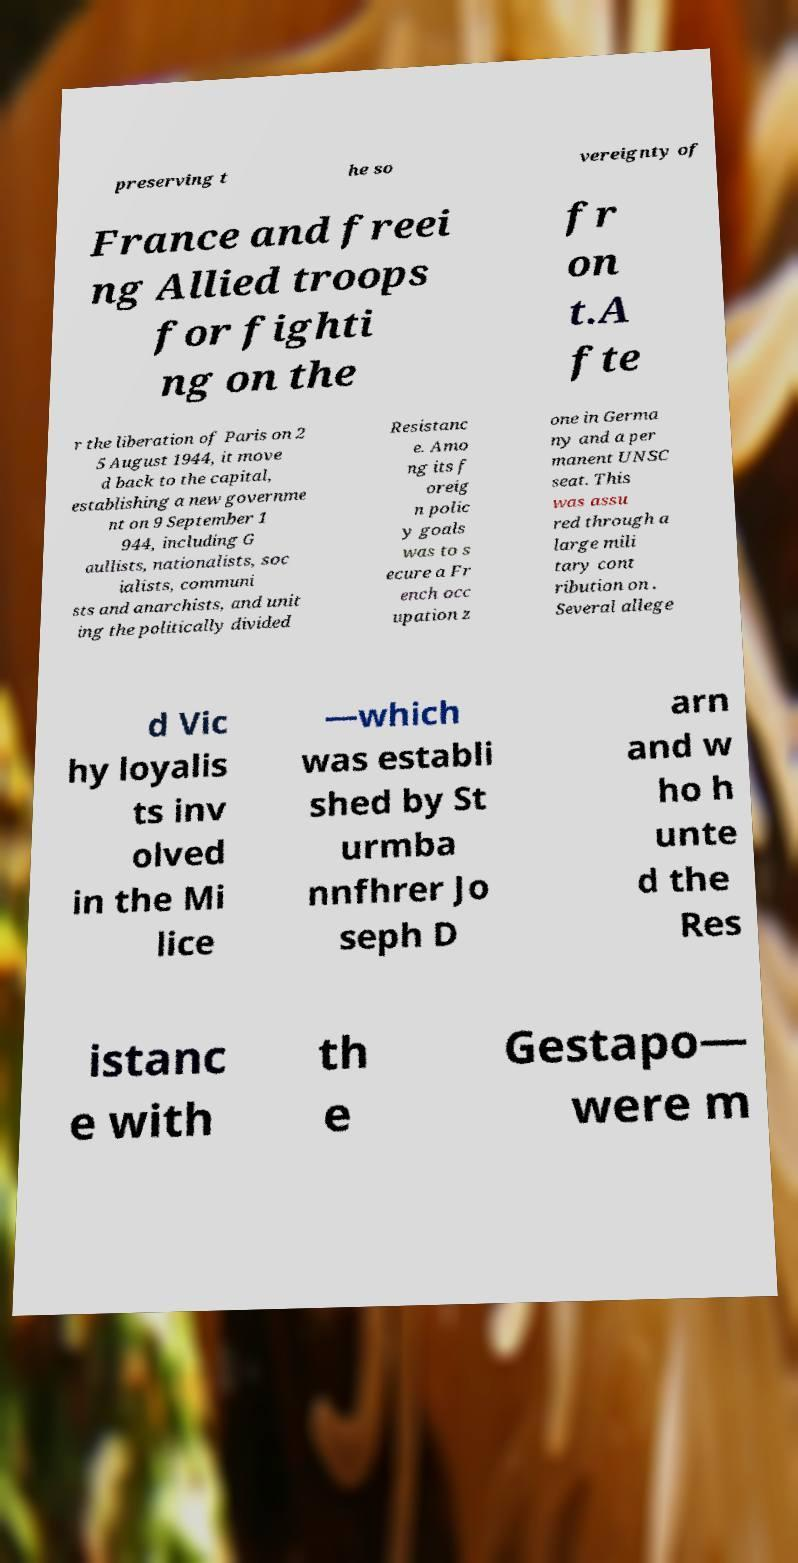For documentation purposes, I need the text within this image transcribed. Could you provide that? preserving t he so vereignty of France and freei ng Allied troops for fighti ng on the fr on t.A fte r the liberation of Paris on 2 5 August 1944, it move d back to the capital, establishing a new governme nt on 9 September 1 944, including G aullists, nationalists, soc ialists, communi sts and anarchists, and unit ing the politically divided Resistanc e. Amo ng its f oreig n polic y goals was to s ecure a Fr ench occ upation z one in Germa ny and a per manent UNSC seat. This was assu red through a large mili tary cont ribution on . Several allege d Vic hy loyalis ts inv olved in the Mi lice —which was establi shed by St urmba nnfhrer Jo seph D arn and w ho h unte d the Res istanc e with th e Gestapo— were m 